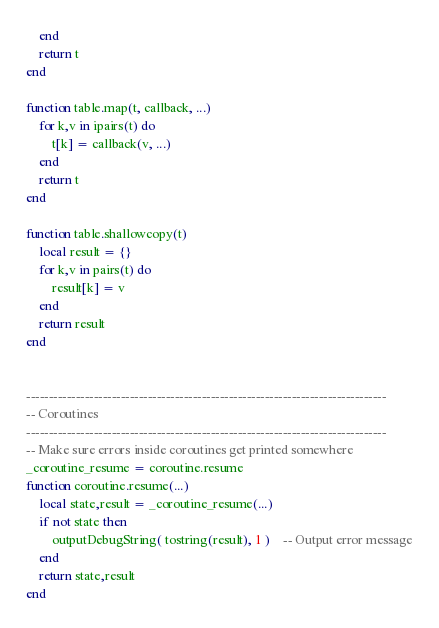Convert code to text. <code><loc_0><loc_0><loc_500><loc_500><_Lua_>	end
	return t
end

function table.map(t, callback, ...)
	for k,v in ipairs(t) do
		t[k] = callback(v, ...)
	end
	return t
end

function table.shallowcopy(t)
	local result = {}
	for k,v in pairs(t) do
		result[k] = v
	end
	return result
end


--------------------------------------------------------------------------------
-- Coroutines
--------------------------------------------------------------------------------
-- Make sure errors inside coroutines get printed somewhere
_coroutine_resume = coroutine.resume
function coroutine.resume(...)
	local state,result = _coroutine_resume(...)
	if not state then
		outputDebugString( tostring(result), 1 )	-- Output error message
	end
	return state,result
end
</code> 